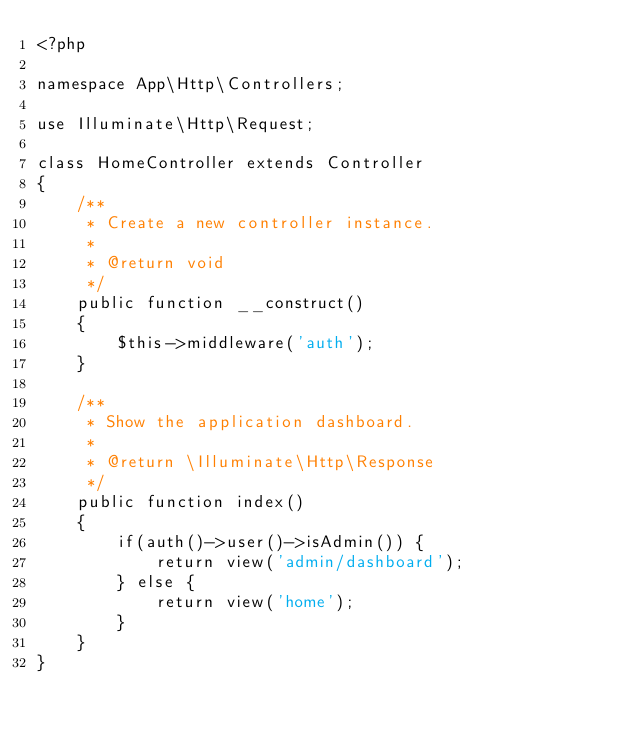<code> <loc_0><loc_0><loc_500><loc_500><_PHP_><?php

namespace App\Http\Controllers;

use Illuminate\Http\Request;

class HomeController extends Controller
{
    /**
     * Create a new controller instance.
     *
     * @return void
     */
    public function __construct()
    {
        $this->middleware('auth');
    }

    /**
     * Show the application dashboard.
     *
     * @return \Illuminate\Http\Response
     */
    public function index()
    {
        if(auth()->user()->isAdmin()) {
            return view('admin/dashboard');
        } else {
            return view('home');
        }
    }
}
</code> 